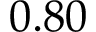<formula> <loc_0><loc_0><loc_500><loc_500>0 . 8 0</formula> 